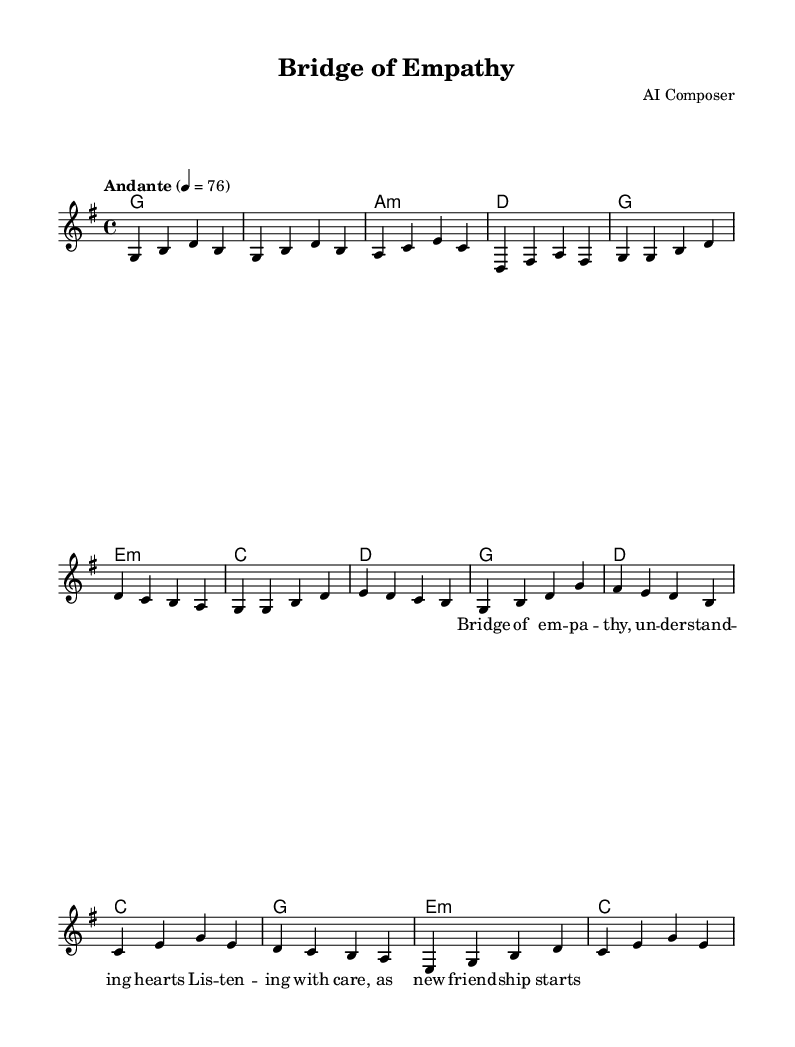What is the key signature of this music? The key signature is G major, which has one sharp (F#). This can be observed by looking at the key signature indicated at the beginning of the score.
Answer: G major What is the time signature of this piece? The time signature is 4/4, meaning there are four beats in each measure and a quarter note receives one beat. This information is located near the beginning of the music notation.
Answer: 4/4 What is the tempo marking of the piece? The tempo marking is "Andante," which indicates a moderate pace. This is shown at the start of the score, indicating how the music should be played.
Answer: Andante What is the last chord in the bridge section? The last chord in the bridge section is C major. This can be identified by checking the chord names listed under the melody, specifically in the bridge part.
Answer: C How many measures are there in the chorus? There are four measures in the chorus. Each measure consists of one complete line of music, and the chorus section is clearly delineated in the notations.
Answer: 4 What do the lyrics in the first verse emphasize? The lyrics emphasize "understanding hearts." This phrase is found within the text associated with the melody, emphasizing empathy and connection, which are central themes in romantic music.
Answer: understanding hearts What style of music does this piece represent? This piece represents Romantic music, as it features gentle acoustic guitar ballads that focus on themes of understanding and empathy. The structure, melody, and focus on emotional expression align with the characteristics of the Romantic style.
Answer: Romantic 